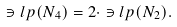Convert formula to latex. <formula><loc_0><loc_0><loc_500><loc_500>\ni l p ( N _ { 4 } ) = 2 \cdot \ni l p ( N _ { 2 } ) .</formula> 